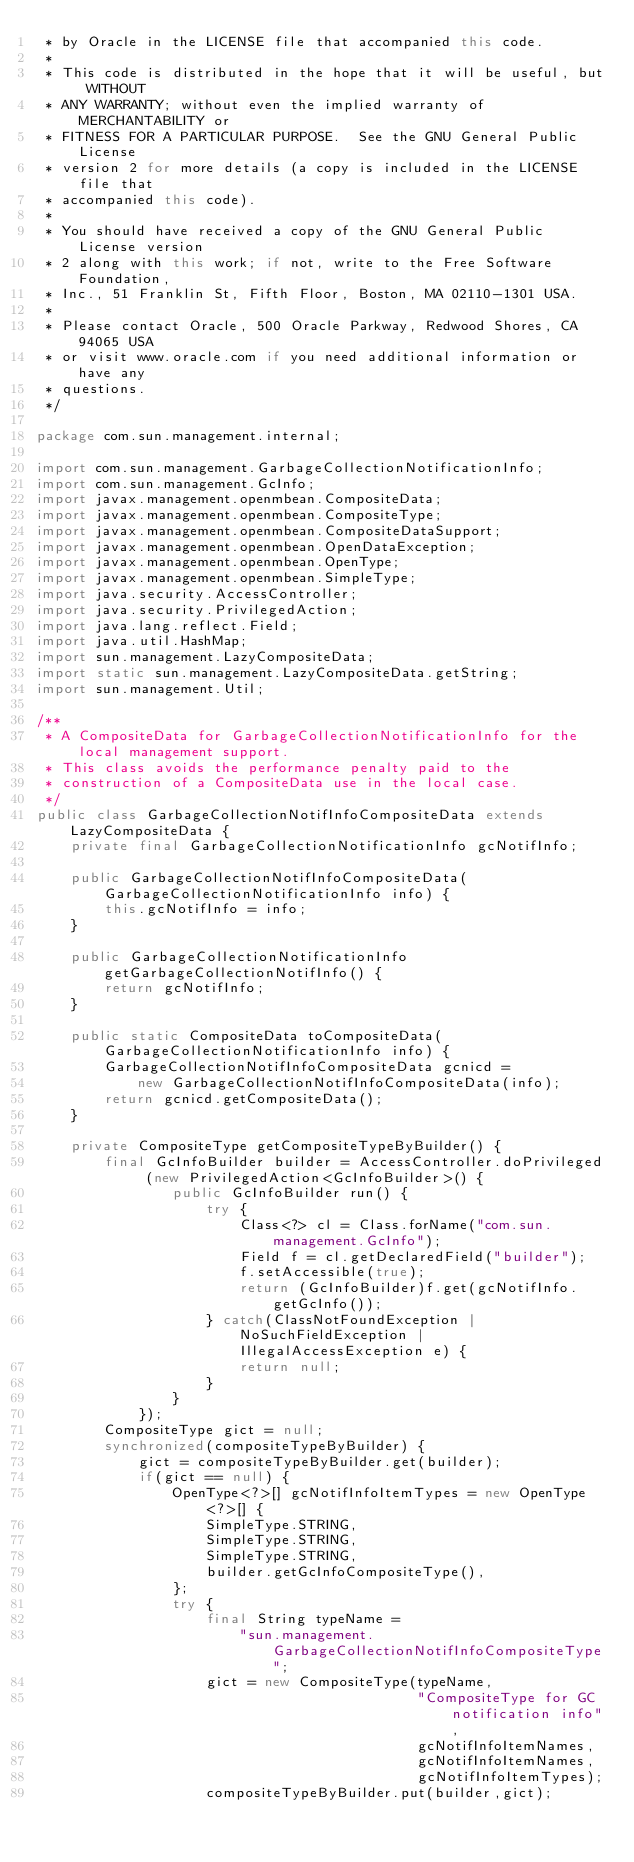<code> <loc_0><loc_0><loc_500><loc_500><_Java_> * by Oracle in the LICENSE file that accompanied this code.
 *
 * This code is distributed in the hope that it will be useful, but WITHOUT
 * ANY WARRANTY; without even the implied warranty of MERCHANTABILITY or
 * FITNESS FOR A PARTICULAR PURPOSE.  See the GNU General Public License
 * version 2 for more details (a copy is included in the LICENSE file that
 * accompanied this code).
 *
 * You should have received a copy of the GNU General Public License version
 * 2 along with this work; if not, write to the Free Software Foundation,
 * Inc., 51 Franklin St, Fifth Floor, Boston, MA 02110-1301 USA.
 *
 * Please contact Oracle, 500 Oracle Parkway, Redwood Shores, CA 94065 USA
 * or visit www.oracle.com if you need additional information or have any
 * questions.
 */

package com.sun.management.internal;

import com.sun.management.GarbageCollectionNotificationInfo;
import com.sun.management.GcInfo;
import javax.management.openmbean.CompositeData;
import javax.management.openmbean.CompositeType;
import javax.management.openmbean.CompositeDataSupport;
import javax.management.openmbean.OpenDataException;
import javax.management.openmbean.OpenType;
import javax.management.openmbean.SimpleType;
import java.security.AccessController;
import java.security.PrivilegedAction;
import java.lang.reflect.Field;
import java.util.HashMap;
import sun.management.LazyCompositeData;
import static sun.management.LazyCompositeData.getString;
import sun.management.Util;

/**
 * A CompositeData for GarbageCollectionNotificationInfo for the local management support.
 * This class avoids the performance penalty paid to the
 * construction of a CompositeData use in the local case.
 */
public class GarbageCollectionNotifInfoCompositeData extends LazyCompositeData {
    private final GarbageCollectionNotificationInfo gcNotifInfo;

    public GarbageCollectionNotifInfoCompositeData(GarbageCollectionNotificationInfo info) {
        this.gcNotifInfo = info;
    }

    public GarbageCollectionNotificationInfo getGarbageCollectionNotifInfo() {
        return gcNotifInfo;
    }

    public static CompositeData toCompositeData(GarbageCollectionNotificationInfo info) {
        GarbageCollectionNotifInfoCompositeData gcnicd =
            new GarbageCollectionNotifInfoCompositeData(info);
        return gcnicd.getCompositeData();
    }

    private CompositeType getCompositeTypeByBuilder() {
        final GcInfoBuilder builder = AccessController.doPrivileged (new PrivilegedAction<GcInfoBuilder>() {
                public GcInfoBuilder run() {
                    try {
                        Class<?> cl = Class.forName("com.sun.management.GcInfo");
                        Field f = cl.getDeclaredField("builder");
                        f.setAccessible(true);
                        return (GcInfoBuilder)f.get(gcNotifInfo.getGcInfo());
                    } catch(ClassNotFoundException | NoSuchFieldException | IllegalAccessException e) {
                        return null;
                    }
                }
            });
        CompositeType gict = null;
        synchronized(compositeTypeByBuilder) {
            gict = compositeTypeByBuilder.get(builder);
            if(gict == null) {
                OpenType<?>[] gcNotifInfoItemTypes = new OpenType<?>[] {
                    SimpleType.STRING,
                    SimpleType.STRING,
                    SimpleType.STRING,
                    builder.getGcInfoCompositeType(),
                };
                try {
                    final String typeName =
                        "sun.management.GarbageCollectionNotifInfoCompositeType";
                    gict = new CompositeType(typeName,
                                             "CompositeType for GC notification info",
                                             gcNotifInfoItemNames,
                                             gcNotifInfoItemNames,
                                             gcNotifInfoItemTypes);
                    compositeTypeByBuilder.put(builder,gict);</code> 